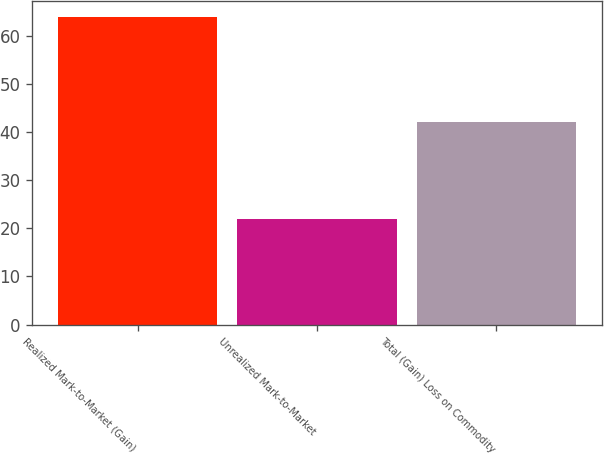<chart> <loc_0><loc_0><loc_500><loc_500><bar_chart><fcel>Realized Mark-to-Market (Gain)<fcel>Unrealized Mark-to-Market<fcel>Total (Gain) Loss on Commodity<nl><fcel>64<fcel>22<fcel>42<nl></chart> 